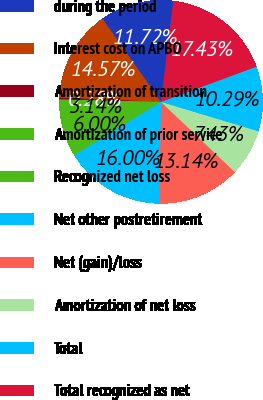Convert chart to OTSL. <chart><loc_0><loc_0><loc_500><loc_500><pie_chart><fcel>during the period<fcel>Interest cost on APBO<fcel>Amortization of transition<fcel>Amortization of prior service<fcel>Recognized net loss<fcel>Net other postretirement<fcel>Net (gain)/loss<fcel>Amortization of net loss<fcel>Total<fcel>Total recognized as net<nl><fcel>11.72%<fcel>14.57%<fcel>0.28%<fcel>3.14%<fcel>6.0%<fcel>16.0%<fcel>13.14%<fcel>7.43%<fcel>10.29%<fcel>17.43%<nl></chart> 